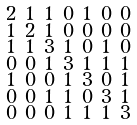<formula> <loc_0><loc_0><loc_500><loc_500>\begin{smallmatrix} 2 & 1 & 1 & 0 & 1 & 0 & 0 \\ 1 & 2 & 1 & 0 & 0 & 0 & 0 \\ 1 & 1 & 3 & 1 & 0 & 1 & 0 \\ 0 & 0 & 1 & 3 & 1 & 1 & 1 \\ 1 & 0 & 0 & 1 & 3 & 0 & 1 \\ 0 & 0 & 1 & 1 & 0 & 3 & 1 \\ 0 & 0 & 0 & 1 & 1 & 1 & 3 \end{smallmatrix}</formula> 